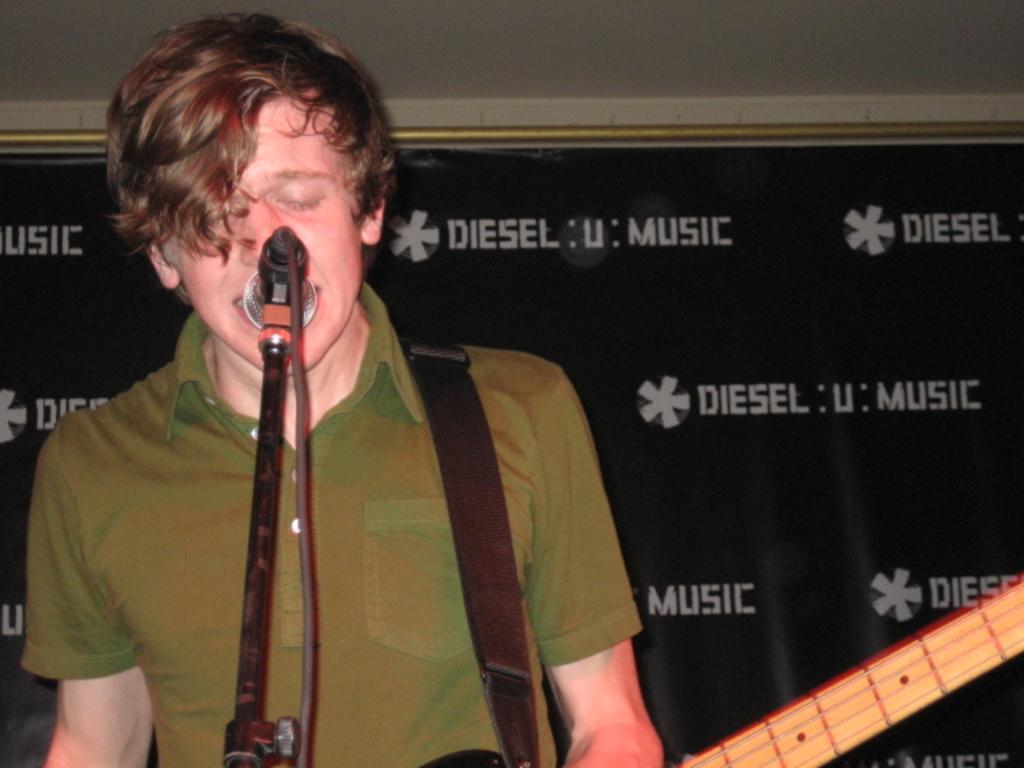Can you describe this image briefly? In the image there is a man holding a guitar and opened his mouth in front of a microphone for singing and background we can see black color hoardings, on top there is a roof which is in white color. 